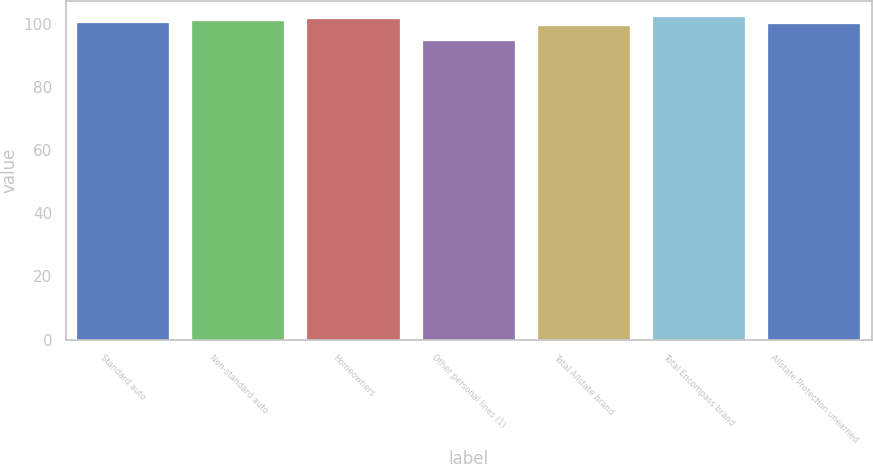<chart> <loc_0><loc_0><loc_500><loc_500><bar_chart><fcel>Standard auto<fcel>Non-standard auto<fcel>Homeowners<fcel>Other personal lines (1)<fcel>Total Allstate brand<fcel>Total Encompass brand<fcel>Allstate Protection unearned<nl><fcel>100.3<fcel>100.85<fcel>101.4<fcel>94.5<fcel>99.2<fcel>101.95<fcel>99.75<nl></chart> 